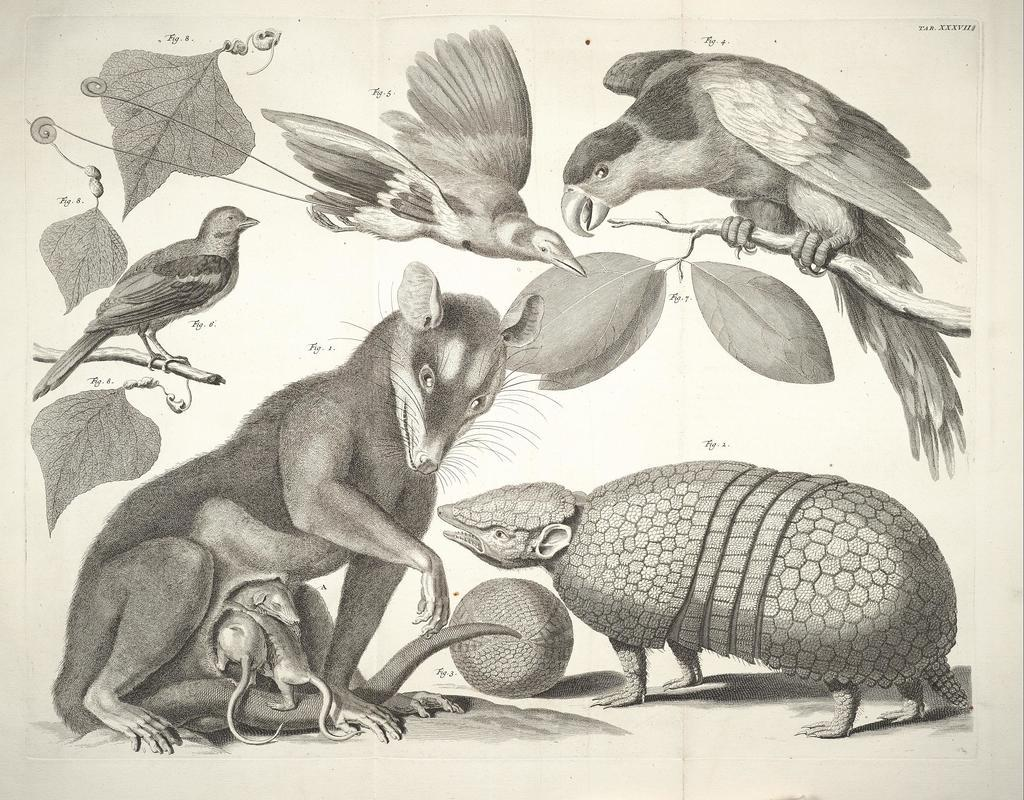What is the color scheme of the image? The image is black and white. What types of drawings can be seen in the image? There are drawings of animals, birds, and leaves in the image. Where is the lunchroom located in the image? There is no lunchroom present in the image; it is a black and white drawing featuring animals, birds, and leaves. What type of canvas is used for the drawings in the image? The type of canvas used for the drawings in the image is not mentioned, as the focus is on the drawings themselves and not the medium they are created on. 